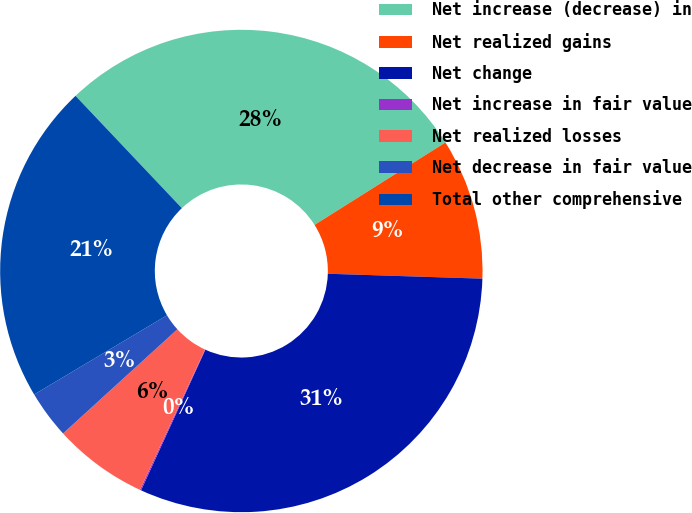Convert chart. <chart><loc_0><loc_0><loc_500><loc_500><pie_chart><fcel>Net increase (decrease) in<fcel>Net realized gains<fcel>Net change<fcel>Net increase in fair value<fcel>Net realized losses<fcel>Net decrease in fair value<fcel>Total other comprehensive<nl><fcel>28.12%<fcel>9.45%<fcel>31.32%<fcel>0.08%<fcel>6.33%<fcel>3.21%<fcel>21.49%<nl></chart> 